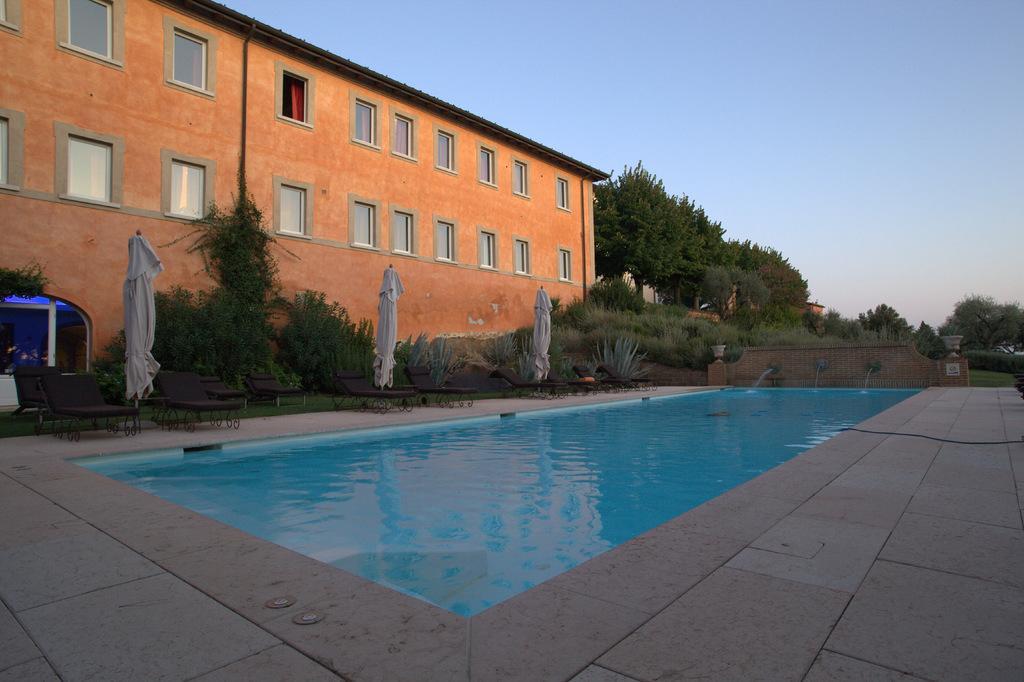Can you describe this image briefly? In this picture I can see the path in front and I can see a swimming pool. In the middle of this picture I can see a building, few plants and few trees. In the background I can see the clear sky and in the middle of this picture I can see few white color clothes. 